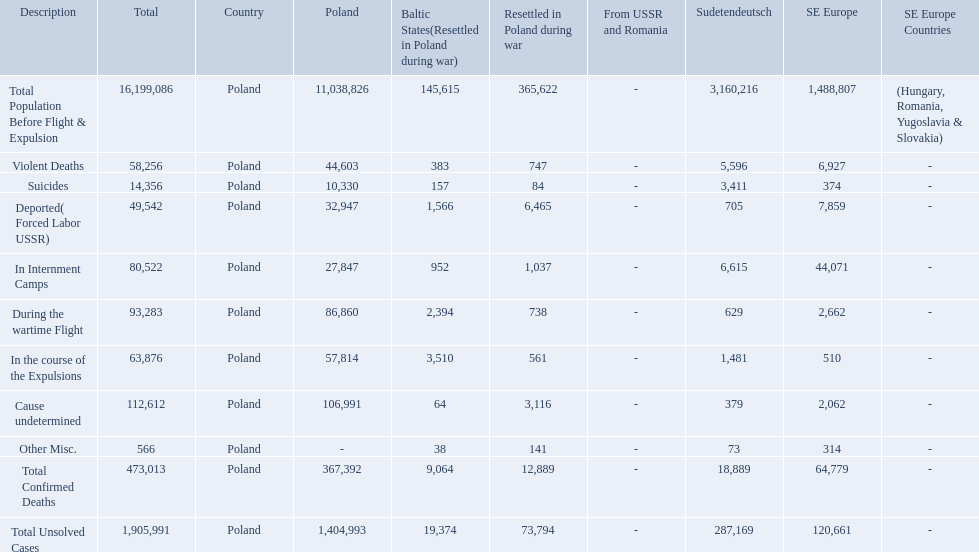What were the total number of confirmed deaths? 473,013. Of these, how many were violent? 58,256. What are all of the descriptions? Total Population Before Flight & Expulsion, Violent Deaths, Suicides, Deported( Forced Labor USSR), In Internment Camps, During the wartime Flight, In the course of the Expulsions, Cause undetermined, Other Misc., Total Confirmed Deaths, Total Unsolved Cases. What were their total number of deaths? 16,199,086, 58,256, 14,356, 49,542, 80,522, 93,283, 63,876, 112,612, 566, 473,013, 1,905,991. What about just from violent deaths? 58,256. How many total confirmed deaths were there in the baltic states? 9,064. How many deaths had an undetermined cause? 64. How many deaths in that region were miscellaneous? 38. Were there more deaths from an undetermined cause or that were listed as miscellaneous? Cause undetermined. 